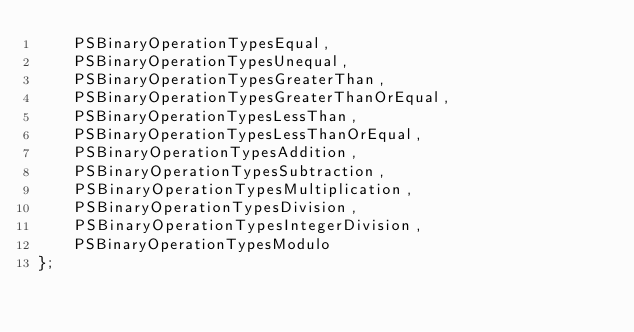<code> <loc_0><loc_0><loc_500><loc_500><_C_>    PSBinaryOperationTypesEqual,
    PSBinaryOperationTypesUnequal,
    PSBinaryOperationTypesGreaterThan,
    PSBinaryOperationTypesGreaterThanOrEqual,
    PSBinaryOperationTypesLessThan,
    PSBinaryOperationTypesLessThanOrEqual,
    PSBinaryOperationTypesAddition,
    PSBinaryOperationTypesSubtraction,
    PSBinaryOperationTypesMultiplication,
    PSBinaryOperationTypesDivision,
    PSBinaryOperationTypesIntegerDivision,
    PSBinaryOperationTypesModulo
};
</code> 